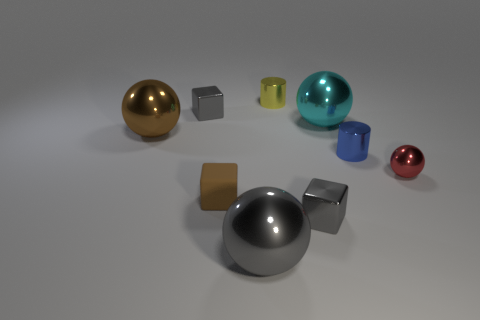Subtract all gray metallic blocks. How many blocks are left? 1 Add 1 large red matte spheres. How many objects exist? 10 Subtract all brown balls. How many balls are left? 3 Subtract 2 cylinders. How many cylinders are left? 0 Subtract 0 red cylinders. How many objects are left? 9 Subtract all balls. How many objects are left? 5 Subtract all brown blocks. Subtract all green cylinders. How many blocks are left? 2 Subtract all gray cylinders. How many gray blocks are left? 2 Subtract all yellow objects. Subtract all tiny blue metallic things. How many objects are left? 7 Add 4 large brown objects. How many large brown objects are left? 5 